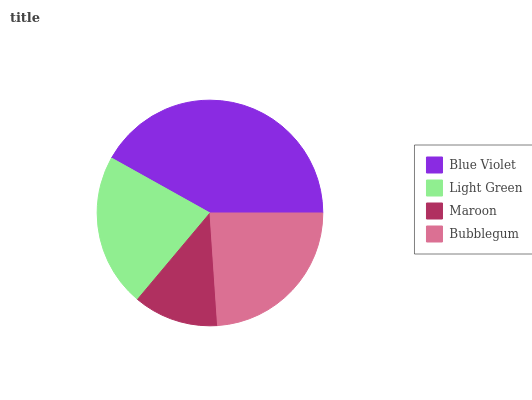Is Maroon the minimum?
Answer yes or no. Yes. Is Blue Violet the maximum?
Answer yes or no. Yes. Is Light Green the minimum?
Answer yes or no. No. Is Light Green the maximum?
Answer yes or no. No. Is Blue Violet greater than Light Green?
Answer yes or no. Yes. Is Light Green less than Blue Violet?
Answer yes or no. Yes. Is Light Green greater than Blue Violet?
Answer yes or no. No. Is Blue Violet less than Light Green?
Answer yes or no. No. Is Bubblegum the high median?
Answer yes or no. Yes. Is Light Green the low median?
Answer yes or no. Yes. Is Blue Violet the high median?
Answer yes or no. No. Is Bubblegum the low median?
Answer yes or no. No. 